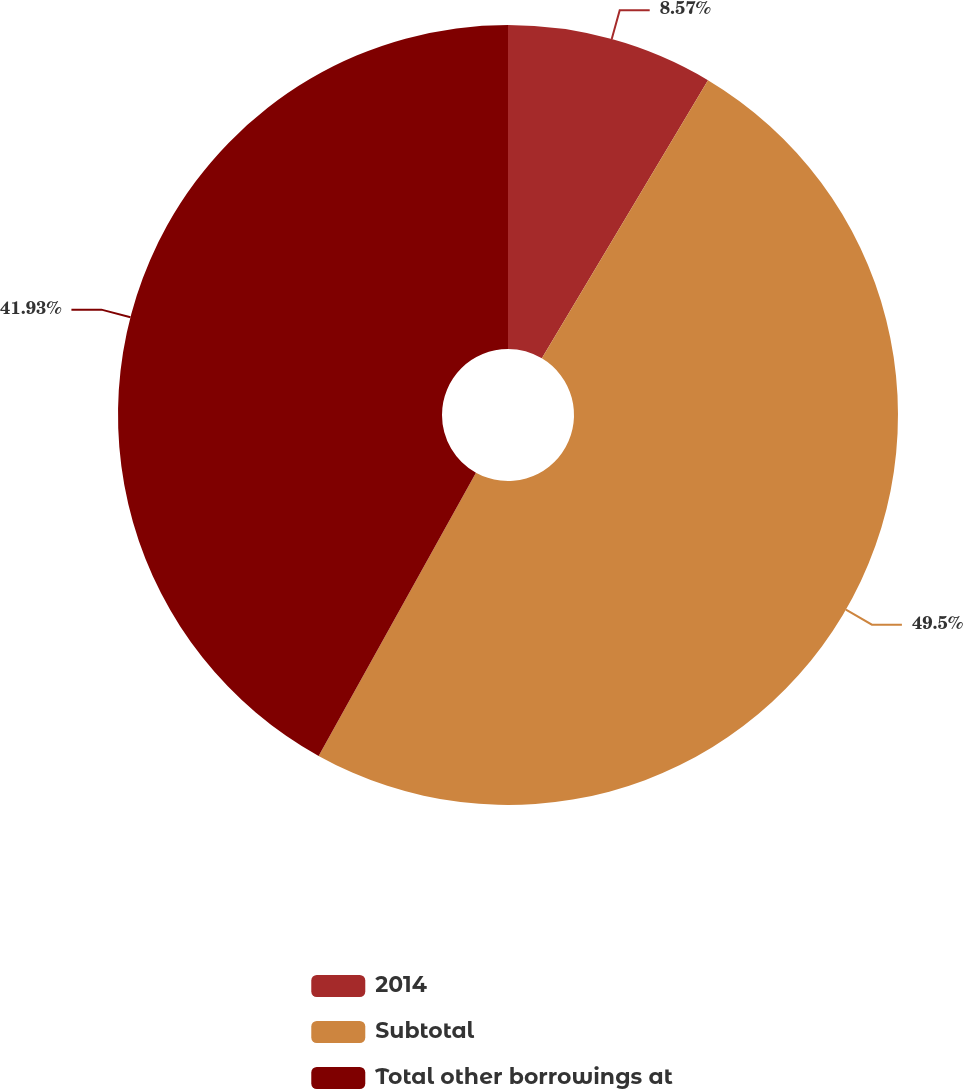<chart> <loc_0><loc_0><loc_500><loc_500><pie_chart><fcel>2014<fcel>Subtotal<fcel>Total other borrowings at<nl><fcel>8.57%<fcel>49.5%<fcel>41.93%<nl></chart> 